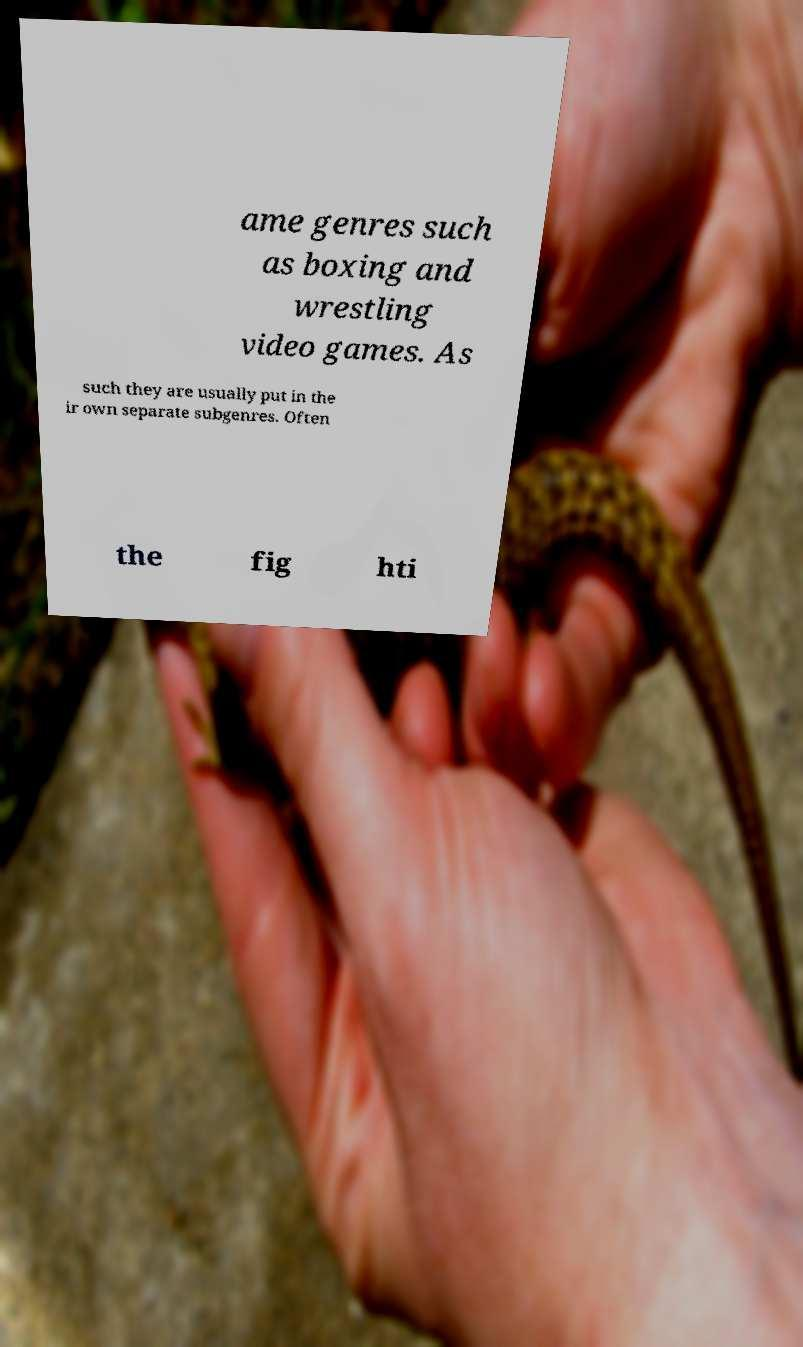For documentation purposes, I need the text within this image transcribed. Could you provide that? ame genres such as boxing and wrestling video games. As such they are usually put in the ir own separate subgenres. Often the fig hti 